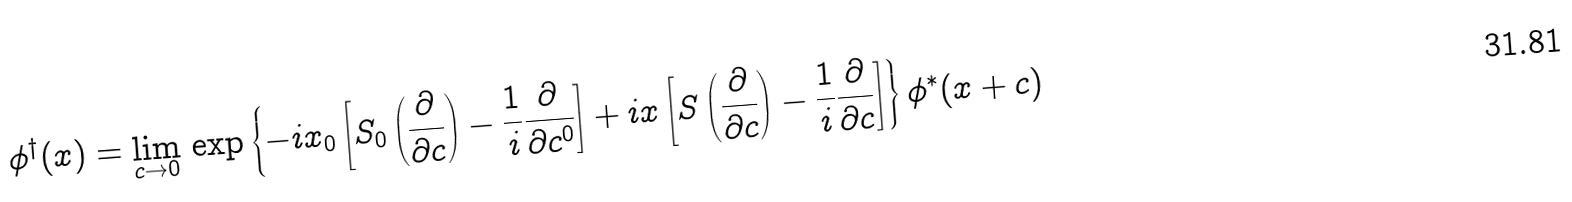Convert formula to latex. <formula><loc_0><loc_0><loc_500><loc_500>\phi ^ { \dag } ( x ) = \lim _ { c \to 0 } \, \exp \left \{ - i x _ { 0 } \left [ S _ { 0 } \left ( \frac { \partial } { \partial c } \right ) - \frac { 1 } { i } \frac { \partial } { \partial c ^ { 0 } } \right ] + i x \left [ S \left ( \frac { \partial } { \partial c } \right ) - \frac { 1 } { i } \frac { \partial } { \partial c } \right ] \right \} \phi ^ { * } ( x + c )</formula> 